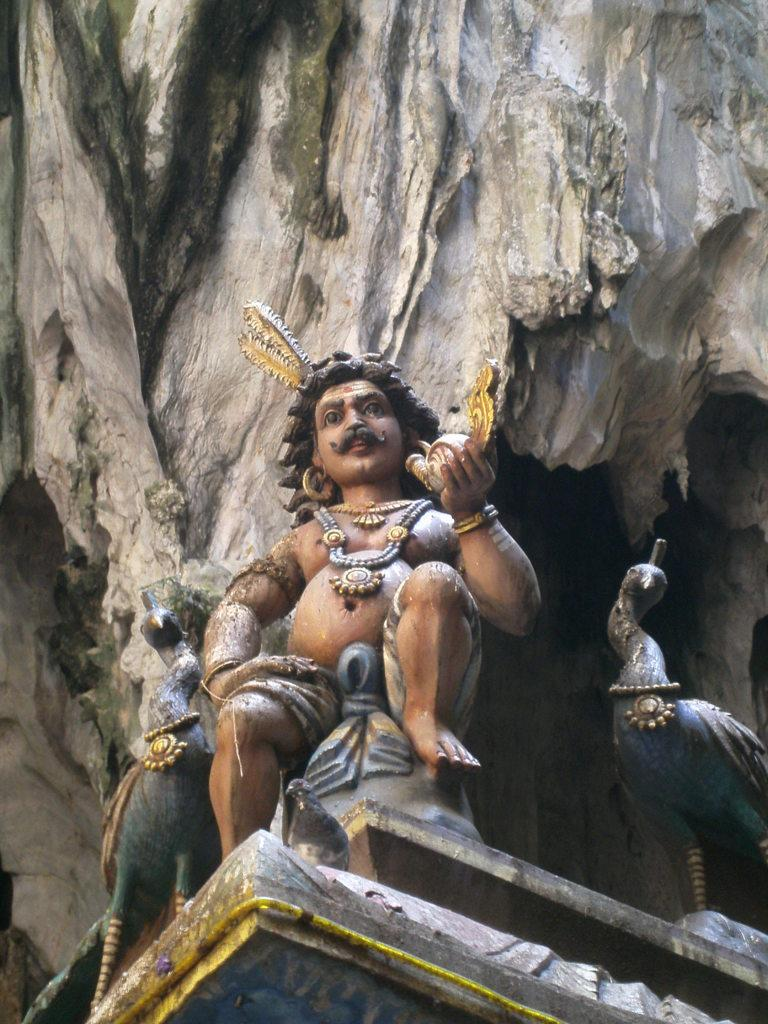What is the main subject of the image? There is a statue of a man in the image. Are there any other statues present in the image? Yes, there are peacock statues on both sides of the man's statue. What can be seen in the background of the image? There is a mountain in the background of the image. What type of riddle is the statue of the man holding in the image? There is no riddle present in the image; it is a statue of a man with peacock statues on both sides and a mountain in the background. 